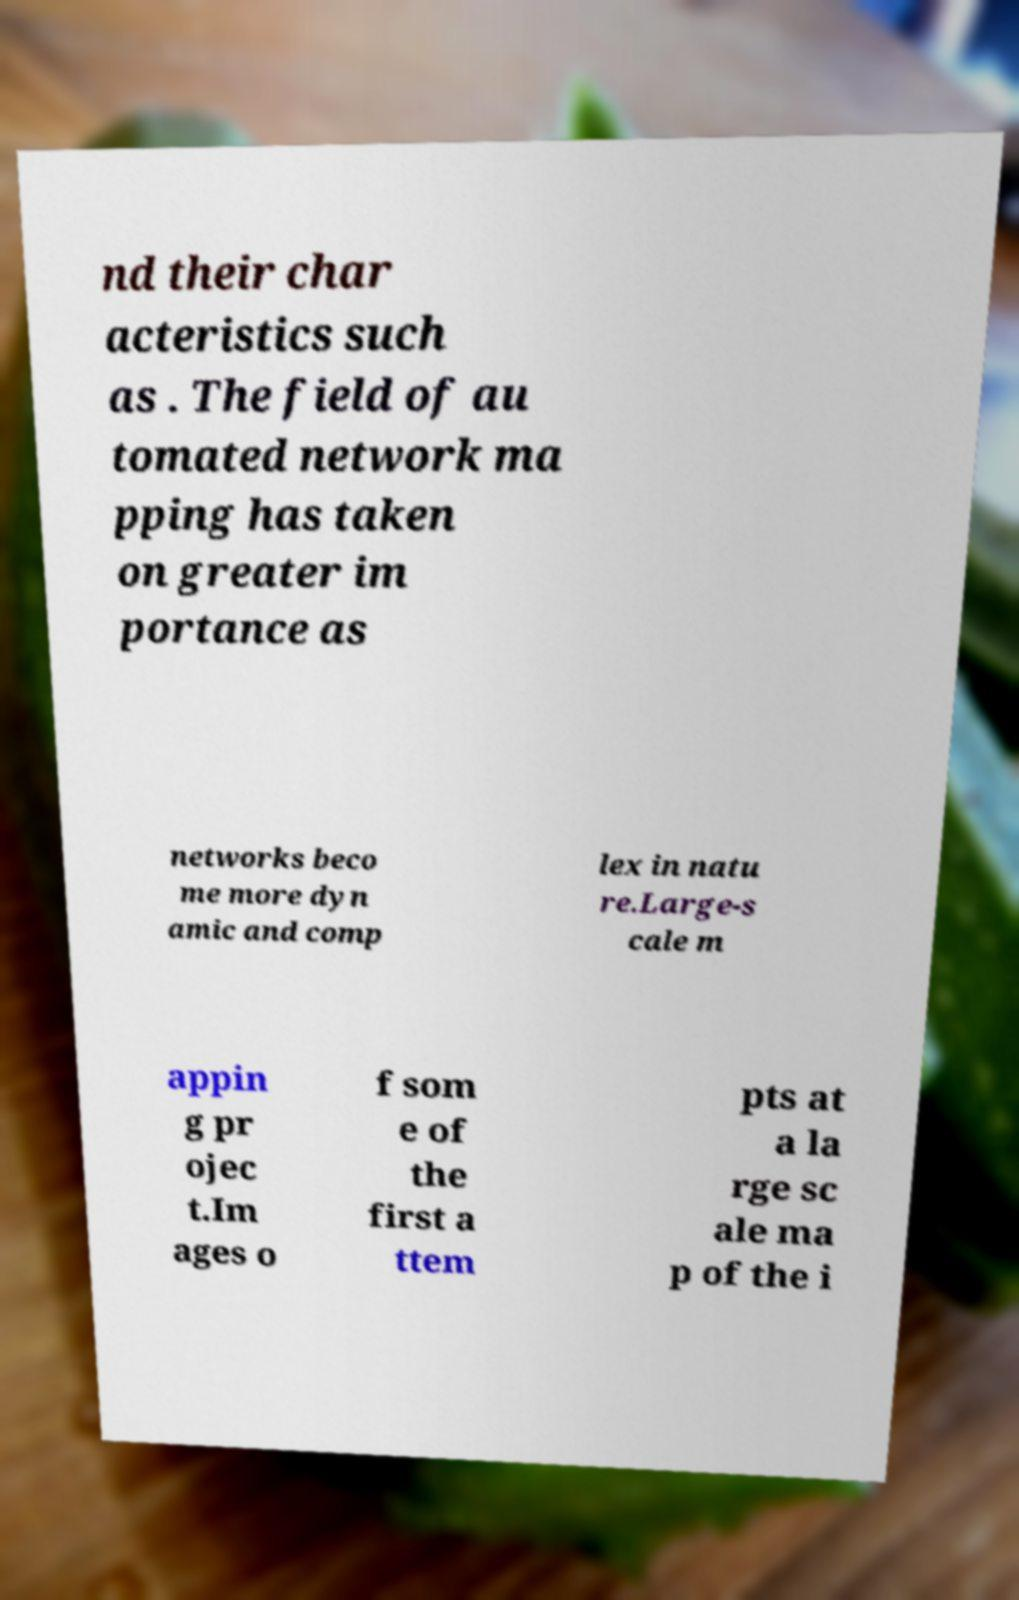Could you extract and type out the text from this image? nd their char acteristics such as . The field of au tomated network ma pping has taken on greater im portance as networks beco me more dyn amic and comp lex in natu re.Large-s cale m appin g pr ojec t.Im ages o f som e of the first a ttem pts at a la rge sc ale ma p of the i 